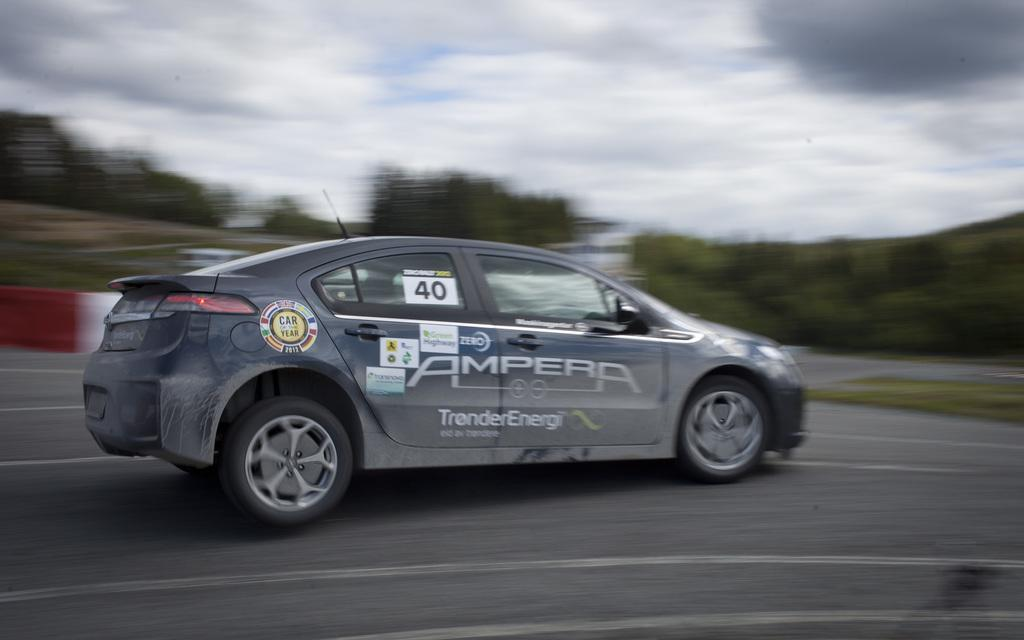What is the main subject of the image? There is a car in the image. Where is the car located? The car is on the road. What can be seen in the background of the image? There are trees, a fence, and the sky visible in the background of the image. Can you determine the time of day the image was taken? The image was likely taken during the day, as the sky is visible and not dark. What type of pies are being served by the coach in the image? There is no coach or pies present in the image; it features a car on the road with a background of trees, a fence, and the sky. 